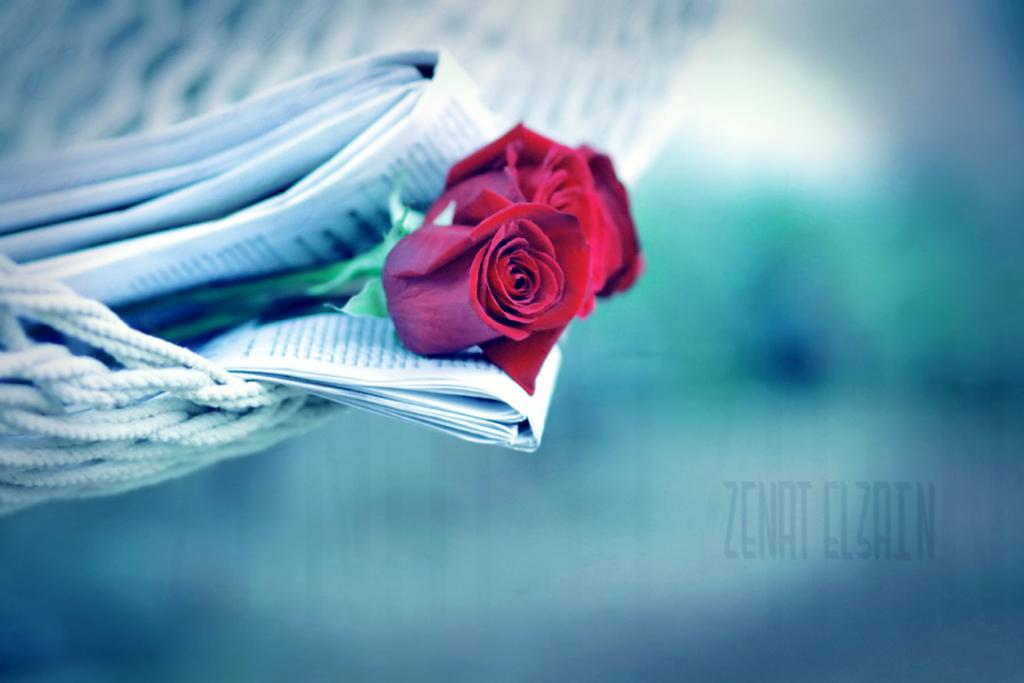What type of flowers can be seen on the left side of the image? There are roses on the left side of the image. What other objects are on the left side of the image? There are newspapers and ropes on the left side of the image. How would you describe the background of the image? The background of the image is blurry. What can be seen on the right side of the image? There is a watermark on the right side of the image. Where is the market located in the image? There is no market present in the image. What type of property is visible in the image? There is no property visible in the image. 